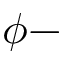Convert formula to latex. <formula><loc_0><loc_0><loc_500><loc_500>\phi -</formula> 